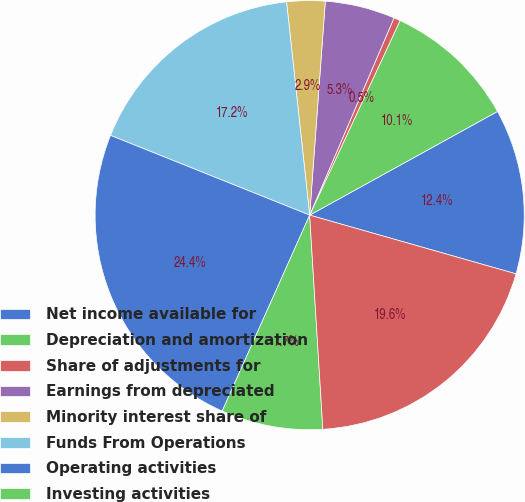Convert chart. <chart><loc_0><loc_0><loc_500><loc_500><pie_chart><fcel>Net income available for<fcel>Depreciation and amortization<fcel>Share of adjustments for<fcel>Earnings from depreciated<fcel>Minority interest share of<fcel>Funds From Operations<fcel>Operating activities<fcel>Investing activities<fcel>Financing activities<nl><fcel>12.44%<fcel>10.05%<fcel>0.49%<fcel>5.27%<fcel>2.88%<fcel>17.22%<fcel>24.38%<fcel>7.66%<fcel>19.61%<nl></chart> 